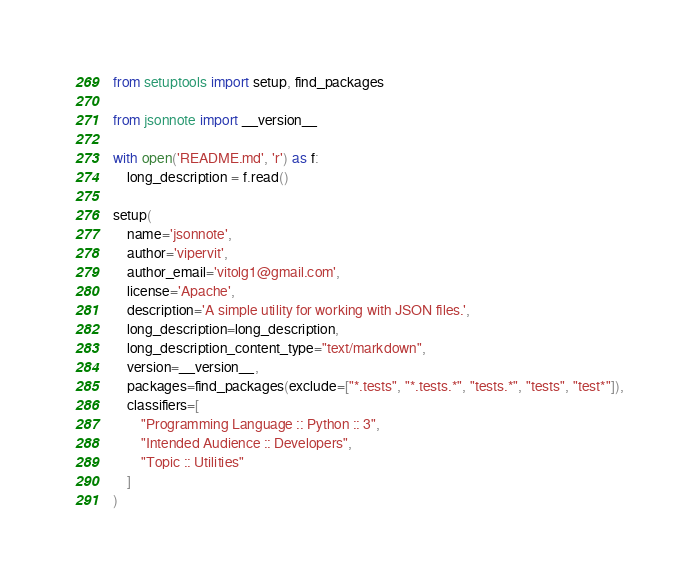Convert code to text. <code><loc_0><loc_0><loc_500><loc_500><_Python_>from setuptools import setup, find_packages

from jsonnote import __version__

with open('README.md', 'r') as f:
    long_description = f.read()

setup(
    name='jsonnote',
    author='vipervit',
    author_email='vitolg1@gmail.com',
    license='Apache',
    description='A simple utility for working with JSON files.',
    long_description=long_description,
    long_description_content_type="text/markdown",
    version=__version__,
    packages=find_packages(exclude=["*.tests", "*.tests.*", "tests.*", "tests", "test*"]),
    classifiers=[
        "Programming Language :: Python :: 3",
        "Intended Audience :: Developers",
        "Topic :: Utilities"
    ]
)
</code> 